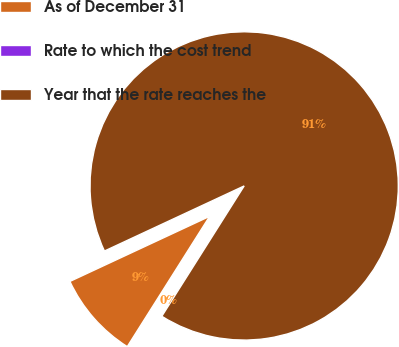<chart> <loc_0><loc_0><loc_500><loc_500><pie_chart><fcel>As of December 31<fcel>Rate to which the cost trend<fcel>Year that the rate reaches the<nl><fcel>9.09%<fcel>0.0%<fcel>90.91%<nl></chart> 